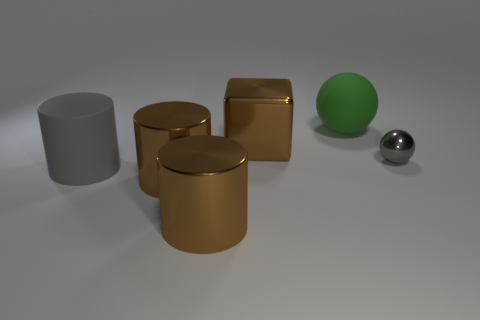Subtract all gray cylinders. How many cylinders are left? 2 Subtract all gray cylinders. How many cylinders are left? 2 Add 3 big green matte balls. How many objects exist? 9 Subtract all spheres. How many objects are left? 4 Subtract 1 cubes. How many cubes are left? 0 Subtract all green spheres. How many gray cylinders are left? 1 Subtract 1 gray balls. How many objects are left? 5 Subtract all purple cylinders. Subtract all green balls. How many cylinders are left? 3 Subtract all rubber balls. Subtract all brown cylinders. How many objects are left? 3 Add 5 brown cylinders. How many brown cylinders are left? 7 